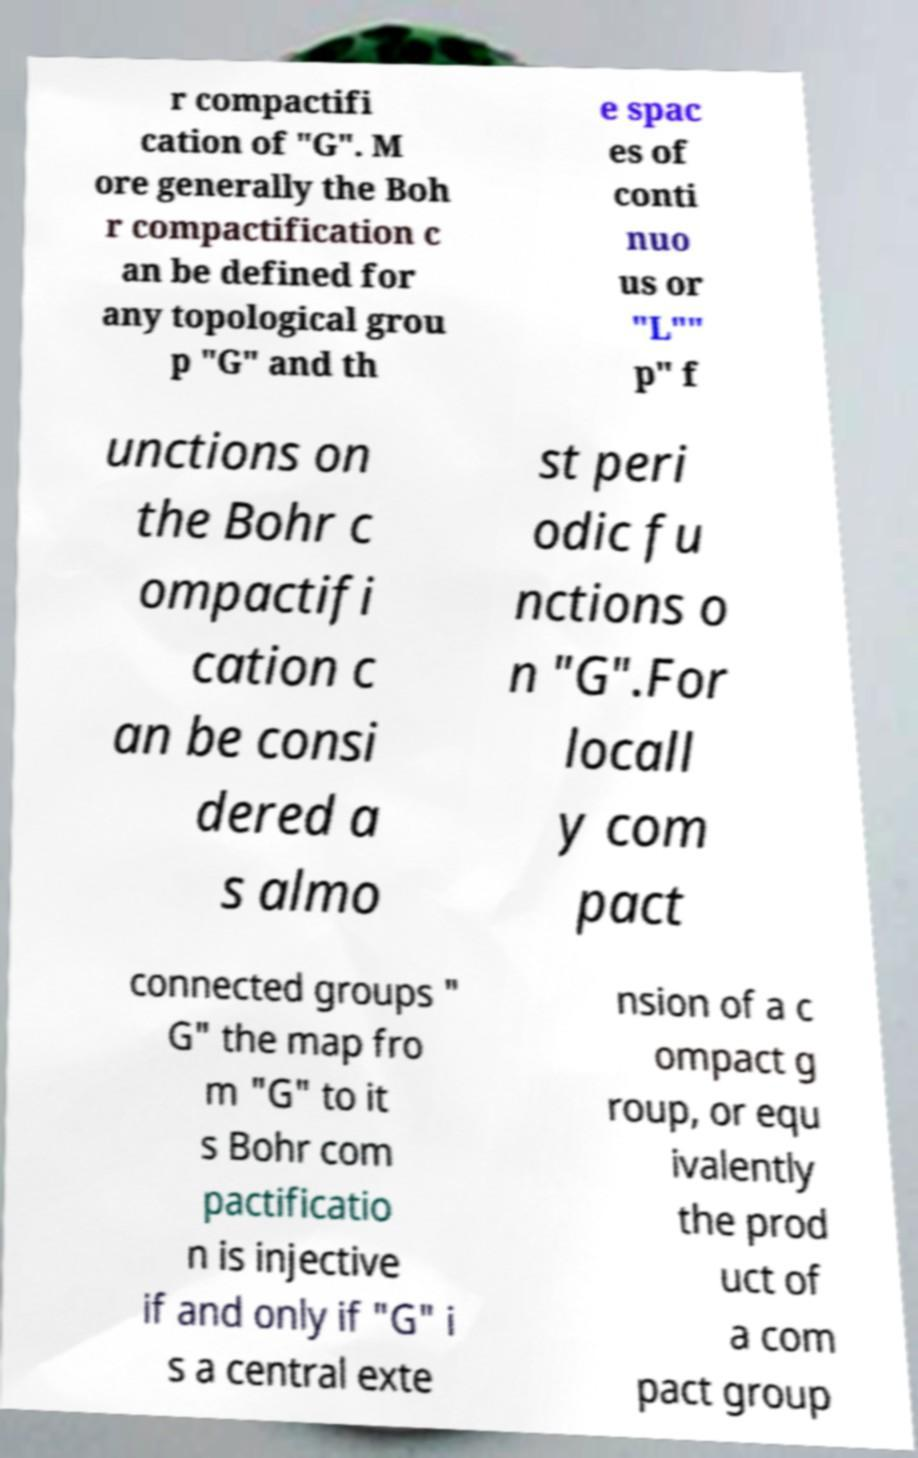Can you accurately transcribe the text from the provided image for me? r compactifi cation of "G". M ore generally the Boh r compactification c an be defined for any topological grou p "G" and th e spac es of conti nuo us or "L"" p" f unctions on the Bohr c ompactifi cation c an be consi dered a s almo st peri odic fu nctions o n "G".For locall y com pact connected groups " G" the map fro m "G" to it s Bohr com pactificatio n is injective if and only if "G" i s a central exte nsion of a c ompact g roup, or equ ivalently the prod uct of a com pact group 